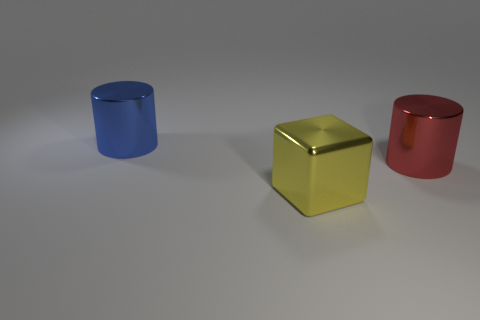Is there anything else of the same color as the big metallic cube?
Offer a very short reply. No. Are there fewer large metal things that are behind the big red metallic cylinder than big gray blocks?
Your response must be concise. No. Are there more large red metallic cylinders than red matte things?
Give a very brief answer. Yes. Are there any large shiny objects left of the cylinder that is right of the object that is on the left side of the cube?
Make the answer very short. Yes. How many other objects are the same size as the metal cube?
Make the answer very short. 2. There is a red object; are there any yellow shiny objects right of it?
Keep it short and to the point. No. There is a large shiny cylinder to the left of the shiny object in front of the shiny cylinder in front of the blue shiny thing; what color is it?
Ensure brevity in your answer.  Blue. Is there a big red metal thing of the same shape as the large blue shiny object?
Your answer should be compact. Yes. The other cylinder that is the same size as the red cylinder is what color?
Ensure brevity in your answer.  Blue. What is the material of the thing that is behind the red metal thing?
Offer a terse response. Metal. 